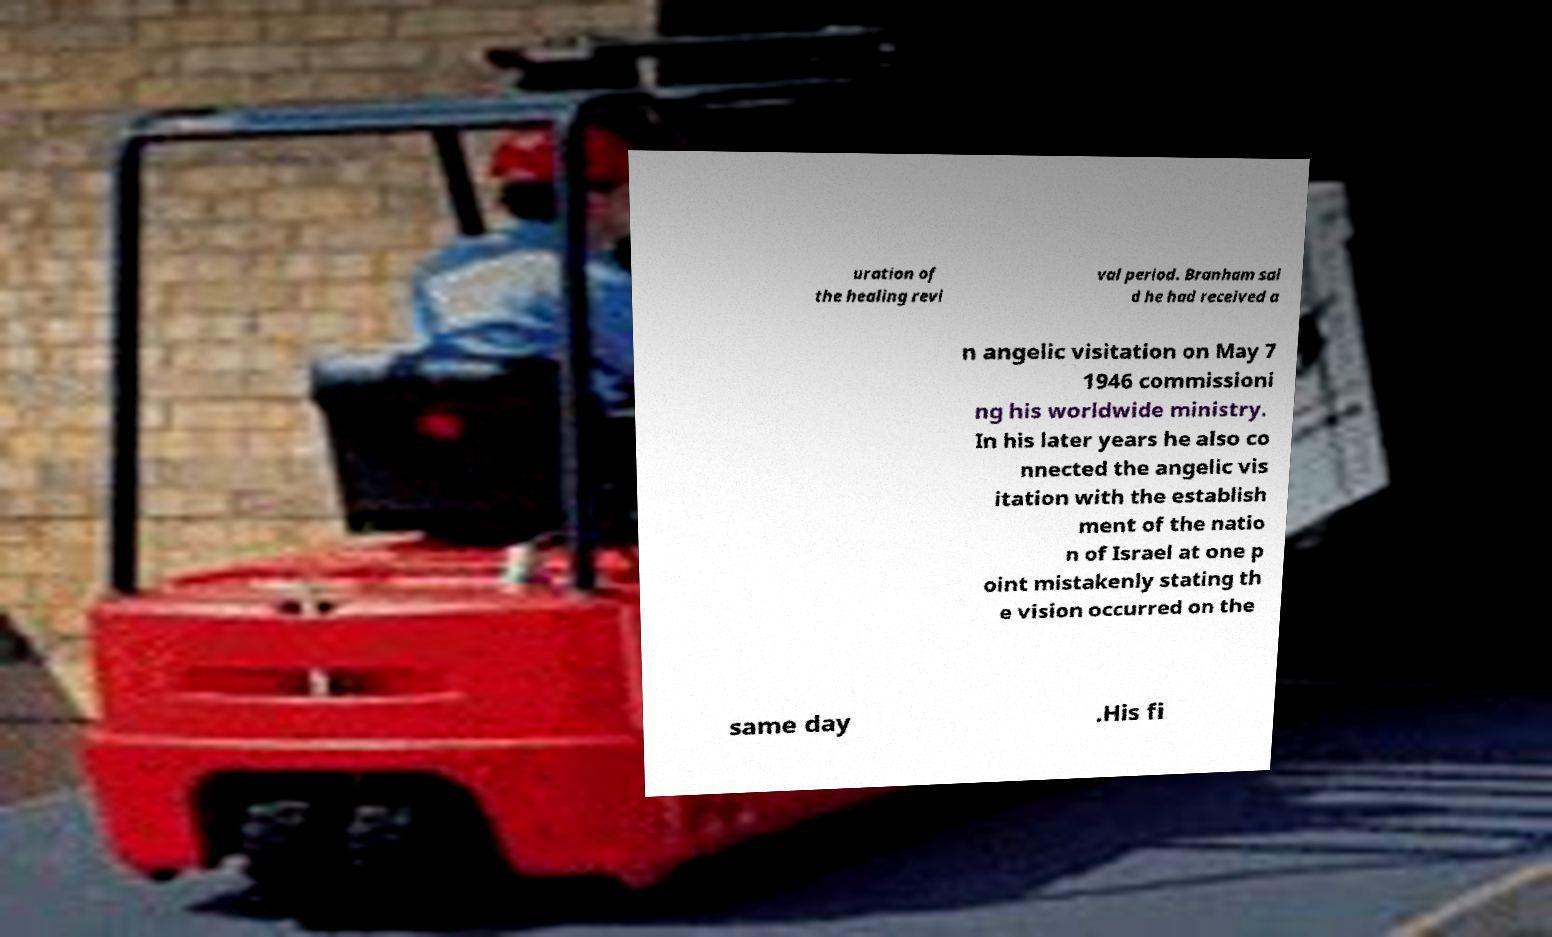There's text embedded in this image that I need extracted. Can you transcribe it verbatim? uration of the healing revi val period. Branham sai d he had received a n angelic visitation on May 7 1946 commissioni ng his worldwide ministry. In his later years he also co nnected the angelic vis itation with the establish ment of the natio n of Israel at one p oint mistakenly stating th e vision occurred on the same day .His fi 